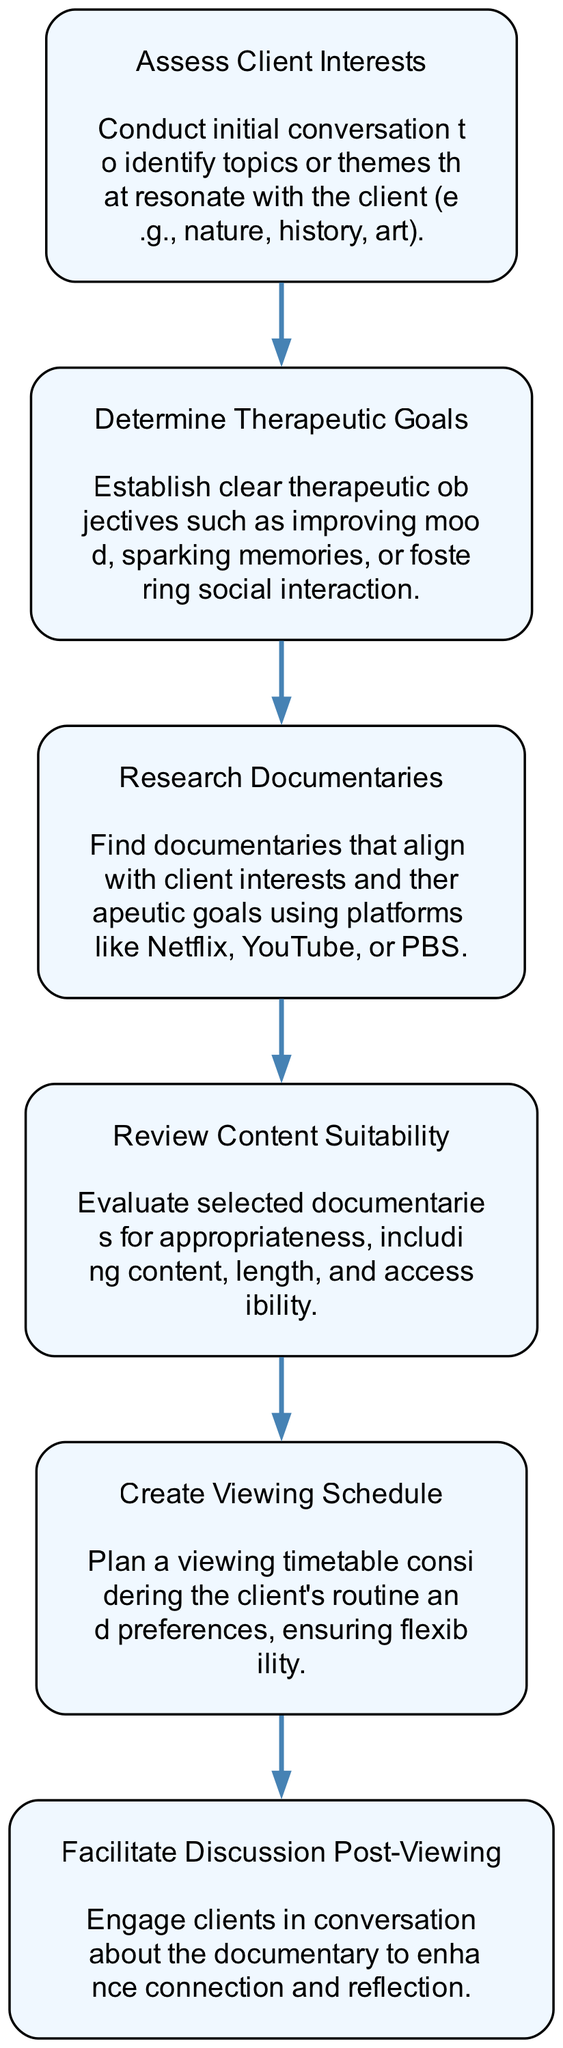What is the first step in the documentary selection process? The first step is represented as the first node in the flowchart, labeled "Assess Client Interests." This indicates that the process starts with assessing what topics or themes resonate with the client.
Answer: Assess Client Interests How many nodes are in the flowchart? The flowchart contains six distinct nodes, each representing a specific step in the documentary selection process.
Answer: 6 What is the therapeutic goal established after "Assess Client Interests"? After assessing client interests, the flowchart shows the next step as "Determine Therapeutic Goals," indicating that the next focus is on setting clear therapeutic objectives.
Answer: Determine Therapeutic Goals What is evaluated in the "Review Content Suitability" step? The "Review Content Suitability" step involves evaluating selected documentaries for aspects such as content appropriateness, length, and accessibility based on the client's needs.
Answer: Content appropriateness, length, and accessibility Which step follows "Research Documentaries"? The step that follows "Research Documentaries" is "Review Content Suitability." This indicates that after researching suitable documentaries, a review of their suitability takes place next.
Answer: Review Content Suitability In terms of flow, what should be done immediately after a documentary is viewed? Immediately after a documentary is viewed, the process emphasizes the step "Facilitate Discussion Post-Viewing," which focuses on engaging clients in conversation about the documentary.
Answer: Facilitate Discussion Post-Viewing Is the "Create Viewing Schedule" step occurring before or after "Determine Therapeutic Goals"? The "Create Viewing Schedule" step occurs after "Determine Therapeutic Goals." This order is established by following the flow from one node to the next in the diagram.
Answer: After What do all arrows in the diagram represent? All arrows in the diagram represent the directional flow of the process, indicating the sequence in which each step should be followed from one node to the next.
Answer: Directional flow of the process 